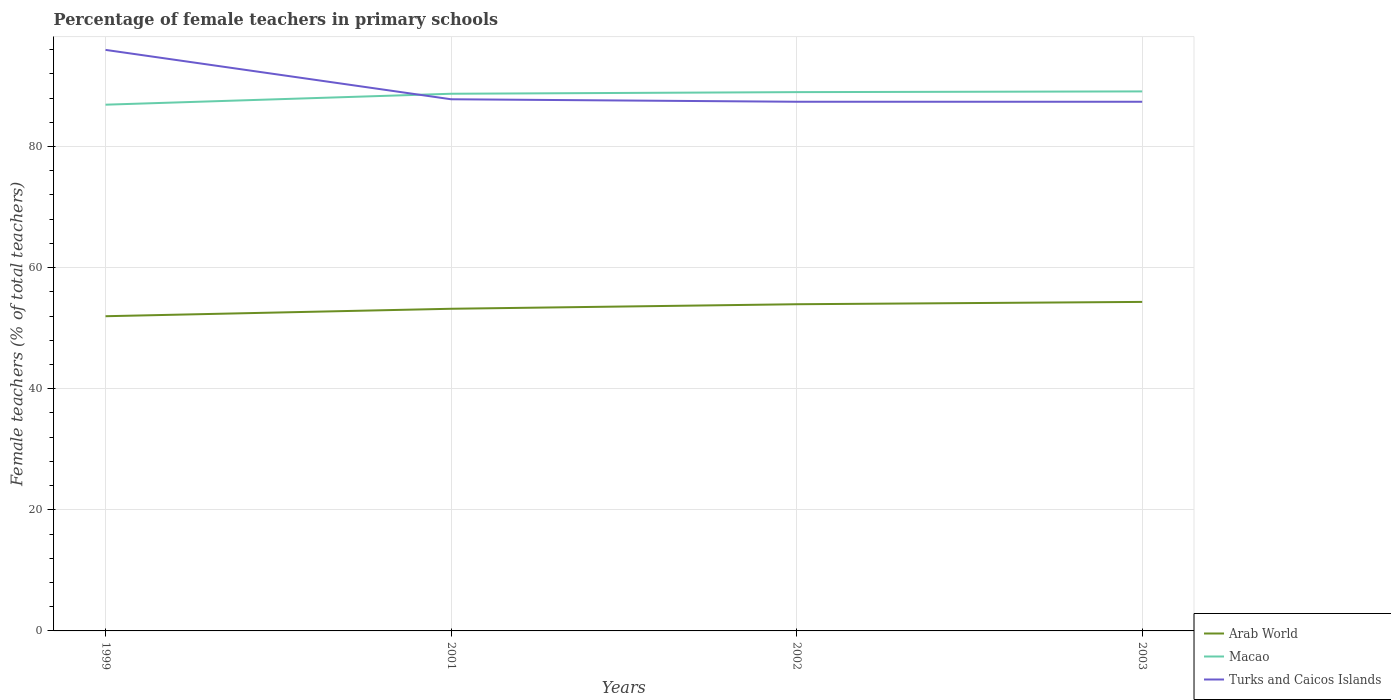How many different coloured lines are there?
Your answer should be very brief. 3. Does the line corresponding to Arab World intersect with the line corresponding to Turks and Caicos Islands?
Provide a succinct answer. No. Is the number of lines equal to the number of legend labels?
Offer a terse response. Yes. Across all years, what is the maximum percentage of female teachers in Turks and Caicos Islands?
Your answer should be very brief. 87.39. In which year was the percentage of female teachers in Macao maximum?
Provide a succinct answer. 1999. What is the total percentage of female teachers in Macao in the graph?
Your answer should be compact. -0.12. What is the difference between the highest and the second highest percentage of female teachers in Macao?
Your response must be concise. 2.19. Is the percentage of female teachers in Turks and Caicos Islands strictly greater than the percentage of female teachers in Arab World over the years?
Your answer should be very brief. No. How many lines are there?
Make the answer very short. 3. How many years are there in the graph?
Your answer should be compact. 4. What is the difference between two consecutive major ticks on the Y-axis?
Provide a succinct answer. 20. Are the values on the major ticks of Y-axis written in scientific E-notation?
Your response must be concise. No. Does the graph contain any zero values?
Provide a succinct answer. No. Does the graph contain grids?
Provide a succinct answer. Yes. Where does the legend appear in the graph?
Give a very brief answer. Bottom right. What is the title of the graph?
Your answer should be very brief. Percentage of female teachers in primary schools. Does "Uzbekistan" appear as one of the legend labels in the graph?
Your answer should be very brief. No. What is the label or title of the Y-axis?
Provide a succinct answer. Female teachers (% of total teachers). What is the Female teachers (% of total teachers) of Arab World in 1999?
Offer a very short reply. 51.97. What is the Female teachers (% of total teachers) of Macao in 1999?
Your answer should be very brief. 86.91. What is the Female teachers (% of total teachers) of Turks and Caicos Islands in 1999?
Offer a very short reply. 95.96. What is the Female teachers (% of total teachers) of Arab World in 2001?
Give a very brief answer. 53.21. What is the Female teachers (% of total teachers) in Macao in 2001?
Keep it short and to the point. 88.72. What is the Female teachers (% of total teachers) in Turks and Caicos Islands in 2001?
Your response must be concise. 87.8. What is the Female teachers (% of total teachers) of Arab World in 2002?
Keep it short and to the point. 53.95. What is the Female teachers (% of total teachers) of Macao in 2002?
Provide a short and direct response. 88.99. What is the Female teachers (% of total teachers) in Turks and Caicos Islands in 2002?
Your answer should be very brief. 87.39. What is the Female teachers (% of total teachers) in Arab World in 2003?
Your answer should be very brief. 54.34. What is the Female teachers (% of total teachers) of Macao in 2003?
Provide a short and direct response. 89.1. What is the Female teachers (% of total teachers) in Turks and Caicos Islands in 2003?
Provide a succinct answer. 87.39. Across all years, what is the maximum Female teachers (% of total teachers) of Arab World?
Make the answer very short. 54.34. Across all years, what is the maximum Female teachers (% of total teachers) in Macao?
Ensure brevity in your answer.  89.1. Across all years, what is the maximum Female teachers (% of total teachers) in Turks and Caicos Islands?
Ensure brevity in your answer.  95.96. Across all years, what is the minimum Female teachers (% of total teachers) of Arab World?
Make the answer very short. 51.97. Across all years, what is the minimum Female teachers (% of total teachers) of Macao?
Give a very brief answer. 86.91. Across all years, what is the minimum Female teachers (% of total teachers) in Turks and Caicos Islands?
Provide a succinct answer. 87.39. What is the total Female teachers (% of total teachers) of Arab World in the graph?
Your response must be concise. 213.47. What is the total Female teachers (% of total teachers) of Macao in the graph?
Keep it short and to the point. 353.71. What is the total Female teachers (% of total teachers) in Turks and Caicos Islands in the graph?
Give a very brief answer. 358.55. What is the difference between the Female teachers (% of total teachers) of Arab World in 1999 and that in 2001?
Give a very brief answer. -1.23. What is the difference between the Female teachers (% of total teachers) of Macao in 1999 and that in 2001?
Your response must be concise. -1.81. What is the difference between the Female teachers (% of total teachers) in Turks and Caicos Islands in 1999 and that in 2001?
Your answer should be compact. 8.15. What is the difference between the Female teachers (% of total teachers) of Arab World in 1999 and that in 2002?
Your answer should be very brief. -1.98. What is the difference between the Female teachers (% of total teachers) in Macao in 1999 and that in 2002?
Your answer should be very brief. -2.07. What is the difference between the Female teachers (% of total teachers) in Turks and Caicos Islands in 1999 and that in 2002?
Your response must be concise. 8.56. What is the difference between the Female teachers (% of total teachers) of Arab World in 1999 and that in 2003?
Offer a terse response. -2.36. What is the difference between the Female teachers (% of total teachers) in Macao in 1999 and that in 2003?
Your answer should be very brief. -2.19. What is the difference between the Female teachers (% of total teachers) of Turks and Caicos Islands in 1999 and that in 2003?
Offer a very short reply. 8.56. What is the difference between the Female teachers (% of total teachers) of Arab World in 2001 and that in 2002?
Provide a succinct answer. -0.75. What is the difference between the Female teachers (% of total teachers) of Macao in 2001 and that in 2002?
Give a very brief answer. -0.27. What is the difference between the Female teachers (% of total teachers) in Turks and Caicos Islands in 2001 and that in 2002?
Make the answer very short. 0.41. What is the difference between the Female teachers (% of total teachers) in Arab World in 2001 and that in 2003?
Ensure brevity in your answer.  -1.13. What is the difference between the Female teachers (% of total teachers) in Macao in 2001 and that in 2003?
Offer a very short reply. -0.39. What is the difference between the Female teachers (% of total teachers) in Turks and Caicos Islands in 2001 and that in 2003?
Ensure brevity in your answer.  0.41. What is the difference between the Female teachers (% of total teachers) of Arab World in 2002 and that in 2003?
Your answer should be compact. -0.38. What is the difference between the Female teachers (% of total teachers) of Macao in 2002 and that in 2003?
Provide a succinct answer. -0.12. What is the difference between the Female teachers (% of total teachers) in Arab World in 1999 and the Female teachers (% of total teachers) in Macao in 2001?
Offer a terse response. -36.74. What is the difference between the Female teachers (% of total teachers) of Arab World in 1999 and the Female teachers (% of total teachers) of Turks and Caicos Islands in 2001?
Provide a short and direct response. -35.83. What is the difference between the Female teachers (% of total teachers) of Macao in 1999 and the Female teachers (% of total teachers) of Turks and Caicos Islands in 2001?
Make the answer very short. -0.89. What is the difference between the Female teachers (% of total teachers) of Arab World in 1999 and the Female teachers (% of total teachers) of Macao in 2002?
Ensure brevity in your answer.  -37.01. What is the difference between the Female teachers (% of total teachers) in Arab World in 1999 and the Female teachers (% of total teachers) in Turks and Caicos Islands in 2002?
Your response must be concise. -35.42. What is the difference between the Female teachers (% of total teachers) in Macao in 1999 and the Female teachers (% of total teachers) in Turks and Caicos Islands in 2002?
Ensure brevity in your answer.  -0.48. What is the difference between the Female teachers (% of total teachers) of Arab World in 1999 and the Female teachers (% of total teachers) of Macao in 2003?
Offer a terse response. -37.13. What is the difference between the Female teachers (% of total teachers) of Arab World in 1999 and the Female teachers (% of total teachers) of Turks and Caicos Islands in 2003?
Make the answer very short. -35.42. What is the difference between the Female teachers (% of total teachers) in Macao in 1999 and the Female teachers (% of total teachers) in Turks and Caicos Islands in 2003?
Provide a succinct answer. -0.48. What is the difference between the Female teachers (% of total teachers) in Arab World in 2001 and the Female teachers (% of total teachers) in Macao in 2002?
Offer a very short reply. -35.78. What is the difference between the Female teachers (% of total teachers) in Arab World in 2001 and the Female teachers (% of total teachers) in Turks and Caicos Islands in 2002?
Offer a very short reply. -34.19. What is the difference between the Female teachers (% of total teachers) in Macao in 2001 and the Female teachers (% of total teachers) in Turks and Caicos Islands in 2002?
Your answer should be very brief. 1.32. What is the difference between the Female teachers (% of total teachers) in Arab World in 2001 and the Female teachers (% of total teachers) in Macao in 2003?
Offer a very short reply. -35.9. What is the difference between the Female teachers (% of total teachers) of Arab World in 2001 and the Female teachers (% of total teachers) of Turks and Caicos Islands in 2003?
Your response must be concise. -34.19. What is the difference between the Female teachers (% of total teachers) in Macao in 2001 and the Female teachers (% of total teachers) in Turks and Caicos Islands in 2003?
Make the answer very short. 1.32. What is the difference between the Female teachers (% of total teachers) in Arab World in 2002 and the Female teachers (% of total teachers) in Macao in 2003?
Your answer should be compact. -35.15. What is the difference between the Female teachers (% of total teachers) of Arab World in 2002 and the Female teachers (% of total teachers) of Turks and Caicos Islands in 2003?
Give a very brief answer. -33.44. What is the difference between the Female teachers (% of total teachers) in Macao in 2002 and the Female teachers (% of total teachers) in Turks and Caicos Islands in 2003?
Provide a short and direct response. 1.59. What is the average Female teachers (% of total teachers) in Arab World per year?
Provide a short and direct response. 53.37. What is the average Female teachers (% of total teachers) of Macao per year?
Keep it short and to the point. 88.43. What is the average Female teachers (% of total teachers) in Turks and Caicos Islands per year?
Ensure brevity in your answer.  89.64. In the year 1999, what is the difference between the Female teachers (% of total teachers) of Arab World and Female teachers (% of total teachers) of Macao?
Give a very brief answer. -34.94. In the year 1999, what is the difference between the Female teachers (% of total teachers) of Arab World and Female teachers (% of total teachers) of Turks and Caicos Islands?
Keep it short and to the point. -43.99. In the year 1999, what is the difference between the Female teachers (% of total teachers) of Macao and Female teachers (% of total teachers) of Turks and Caicos Islands?
Provide a succinct answer. -9.05. In the year 2001, what is the difference between the Female teachers (% of total teachers) in Arab World and Female teachers (% of total teachers) in Macao?
Offer a very short reply. -35.51. In the year 2001, what is the difference between the Female teachers (% of total teachers) of Arab World and Female teachers (% of total teachers) of Turks and Caicos Islands?
Make the answer very short. -34.6. In the year 2001, what is the difference between the Female teachers (% of total teachers) in Macao and Female teachers (% of total teachers) in Turks and Caicos Islands?
Your response must be concise. 0.91. In the year 2002, what is the difference between the Female teachers (% of total teachers) of Arab World and Female teachers (% of total teachers) of Macao?
Your answer should be very brief. -35.03. In the year 2002, what is the difference between the Female teachers (% of total teachers) in Arab World and Female teachers (% of total teachers) in Turks and Caicos Islands?
Ensure brevity in your answer.  -33.44. In the year 2002, what is the difference between the Female teachers (% of total teachers) of Macao and Female teachers (% of total teachers) of Turks and Caicos Islands?
Keep it short and to the point. 1.59. In the year 2003, what is the difference between the Female teachers (% of total teachers) of Arab World and Female teachers (% of total teachers) of Macao?
Ensure brevity in your answer.  -34.76. In the year 2003, what is the difference between the Female teachers (% of total teachers) in Arab World and Female teachers (% of total teachers) in Turks and Caicos Islands?
Offer a terse response. -33.06. In the year 2003, what is the difference between the Female teachers (% of total teachers) of Macao and Female teachers (% of total teachers) of Turks and Caicos Islands?
Provide a short and direct response. 1.71. What is the ratio of the Female teachers (% of total teachers) of Arab World in 1999 to that in 2001?
Your answer should be very brief. 0.98. What is the ratio of the Female teachers (% of total teachers) of Macao in 1999 to that in 2001?
Make the answer very short. 0.98. What is the ratio of the Female teachers (% of total teachers) in Turks and Caicos Islands in 1999 to that in 2001?
Make the answer very short. 1.09. What is the ratio of the Female teachers (% of total teachers) in Arab World in 1999 to that in 2002?
Provide a short and direct response. 0.96. What is the ratio of the Female teachers (% of total teachers) in Macao in 1999 to that in 2002?
Make the answer very short. 0.98. What is the ratio of the Female teachers (% of total teachers) in Turks and Caicos Islands in 1999 to that in 2002?
Provide a short and direct response. 1.1. What is the ratio of the Female teachers (% of total teachers) in Arab World in 1999 to that in 2003?
Your answer should be compact. 0.96. What is the ratio of the Female teachers (% of total teachers) in Macao in 1999 to that in 2003?
Offer a very short reply. 0.98. What is the ratio of the Female teachers (% of total teachers) of Turks and Caicos Islands in 1999 to that in 2003?
Your response must be concise. 1.1. What is the ratio of the Female teachers (% of total teachers) of Arab World in 2001 to that in 2002?
Make the answer very short. 0.99. What is the ratio of the Female teachers (% of total teachers) of Macao in 2001 to that in 2002?
Your answer should be compact. 1. What is the ratio of the Female teachers (% of total teachers) in Turks and Caicos Islands in 2001 to that in 2002?
Make the answer very short. 1. What is the ratio of the Female teachers (% of total teachers) in Arab World in 2001 to that in 2003?
Give a very brief answer. 0.98. What is the ratio of the Female teachers (% of total teachers) in Macao in 2002 to that in 2003?
Ensure brevity in your answer.  1. What is the difference between the highest and the second highest Female teachers (% of total teachers) in Arab World?
Provide a short and direct response. 0.38. What is the difference between the highest and the second highest Female teachers (% of total teachers) in Macao?
Provide a succinct answer. 0.12. What is the difference between the highest and the second highest Female teachers (% of total teachers) in Turks and Caicos Islands?
Offer a terse response. 8.15. What is the difference between the highest and the lowest Female teachers (% of total teachers) in Arab World?
Your response must be concise. 2.36. What is the difference between the highest and the lowest Female teachers (% of total teachers) of Macao?
Your answer should be very brief. 2.19. What is the difference between the highest and the lowest Female teachers (% of total teachers) of Turks and Caicos Islands?
Ensure brevity in your answer.  8.56. 